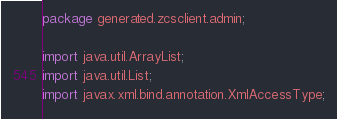<code> <loc_0><loc_0><loc_500><loc_500><_Java_>
package generated.zcsclient.admin;

import java.util.ArrayList;
import java.util.List;
import javax.xml.bind.annotation.XmlAccessType;</code> 